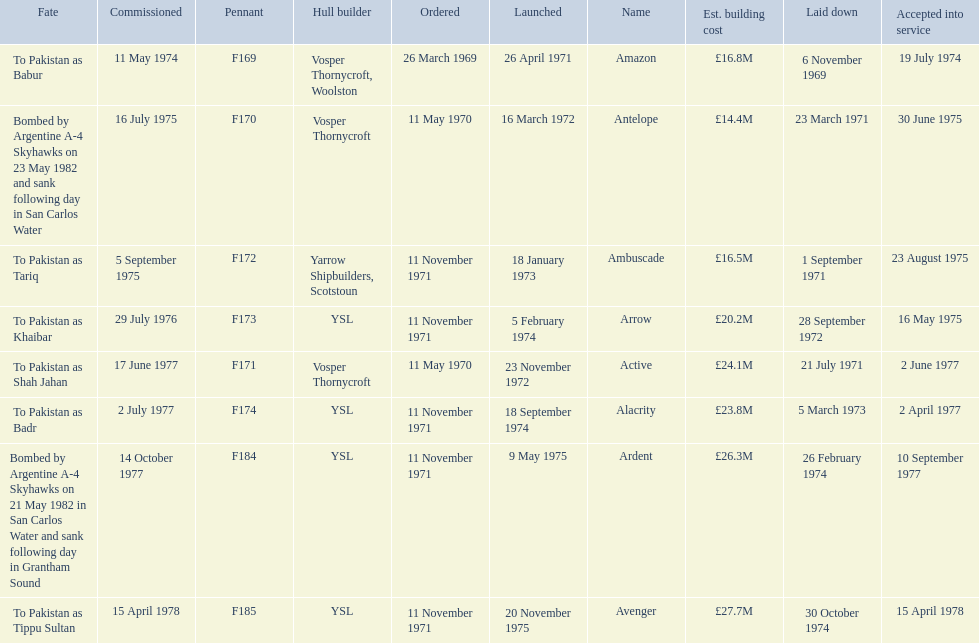What were the estimated building costs of the frigates? £16.8M, £14.4M, £16.5M, £20.2M, £24.1M, £23.8M, £26.3M, £27.7M. Which of these is the largest? £27.7M. What ship name does that correspond to? Avenger. 